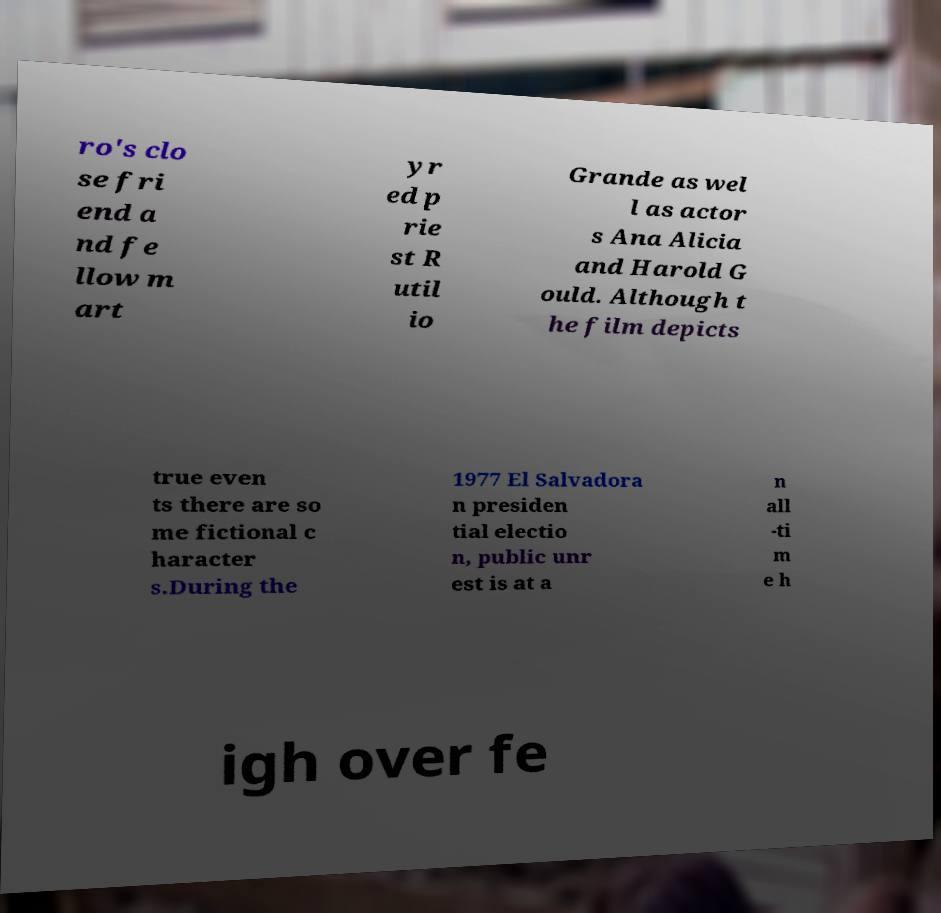There's text embedded in this image that I need extracted. Can you transcribe it verbatim? ro's clo se fri end a nd fe llow m art yr ed p rie st R util io Grande as wel l as actor s Ana Alicia and Harold G ould. Although t he film depicts true even ts there are so me fictional c haracter s.During the 1977 El Salvadora n presiden tial electio n, public unr est is at a n all -ti m e h igh over fe 